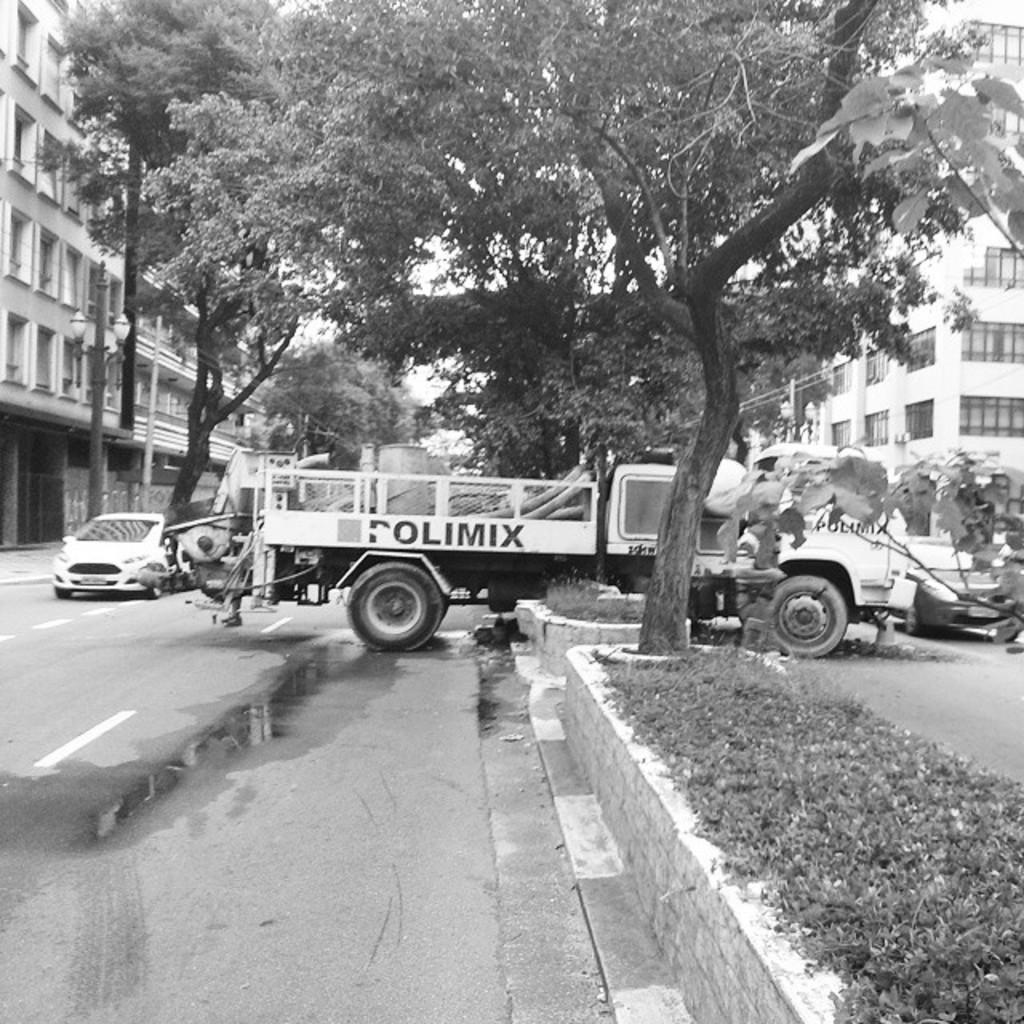What is located in the center of the image? There are vehicles in the center of the image. What is at the bottom of the image? There is a road and plants at the bottom of the image. What can be seen in the background of the image? There are buildings and trees in the background of the image. What type of letter is being delivered by the vehicles in the image? There is no indication of a letter being delivered in the image; it simply shows vehicles on a road. How is the cork used in the image? There is no cork present in the image. 